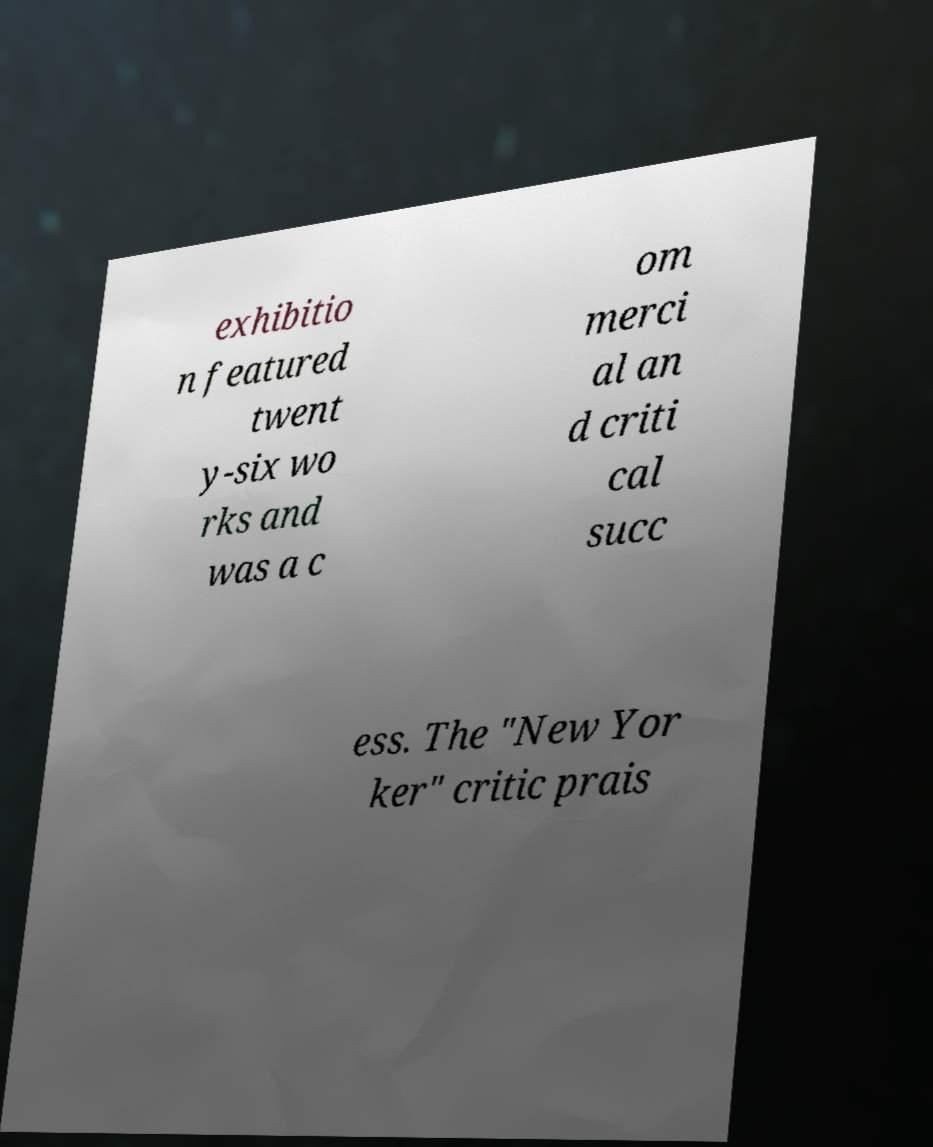For documentation purposes, I need the text within this image transcribed. Could you provide that? exhibitio n featured twent y-six wo rks and was a c om merci al an d criti cal succ ess. The "New Yor ker" critic prais 